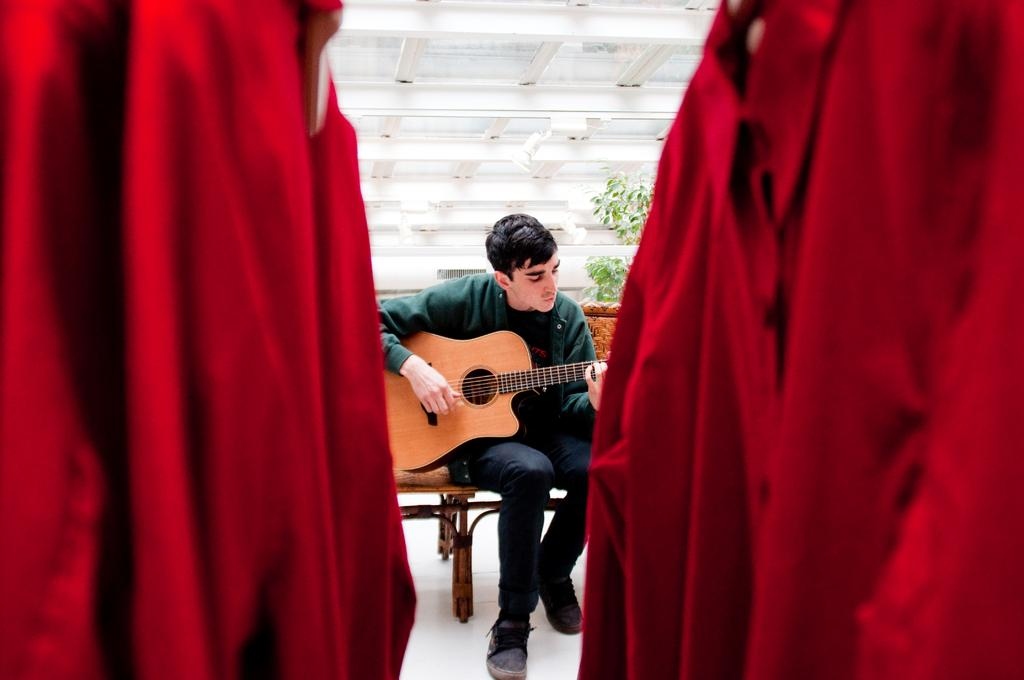Who is the main subject in the image? There is a man in the image. What is the man doing in the image? The man is sitting on a chair and playing a guitar. What can be seen in the background of the image? There is a tree visible in the background of the image. What is present in the foreground of the image? There are clothes in the foreground of the image. How far away is the ant from the man in the image? There is no ant present in the image, so it is not possible to determine the distance between the man and an ant. 